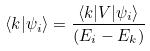Convert formula to latex. <formula><loc_0><loc_0><loc_500><loc_500>\langle k | \psi _ { i } \rangle = \frac { \langle k | V | \psi _ { i } \rangle } { ( E _ { i } - E _ { k } ) }</formula> 